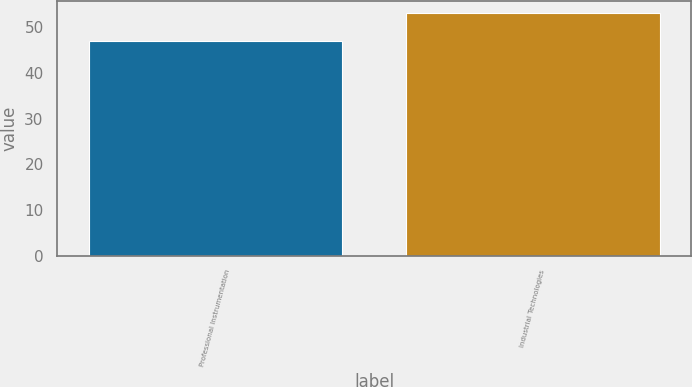Convert chart to OTSL. <chart><loc_0><loc_0><loc_500><loc_500><bar_chart><fcel>Professional Instrumentation<fcel>Industrial Technologies<nl><fcel>47<fcel>53<nl></chart> 